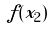Convert formula to latex. <formula><loc_0><loc_0><loc_500><loc_500>f ( x _ { 2 } )</formula> 